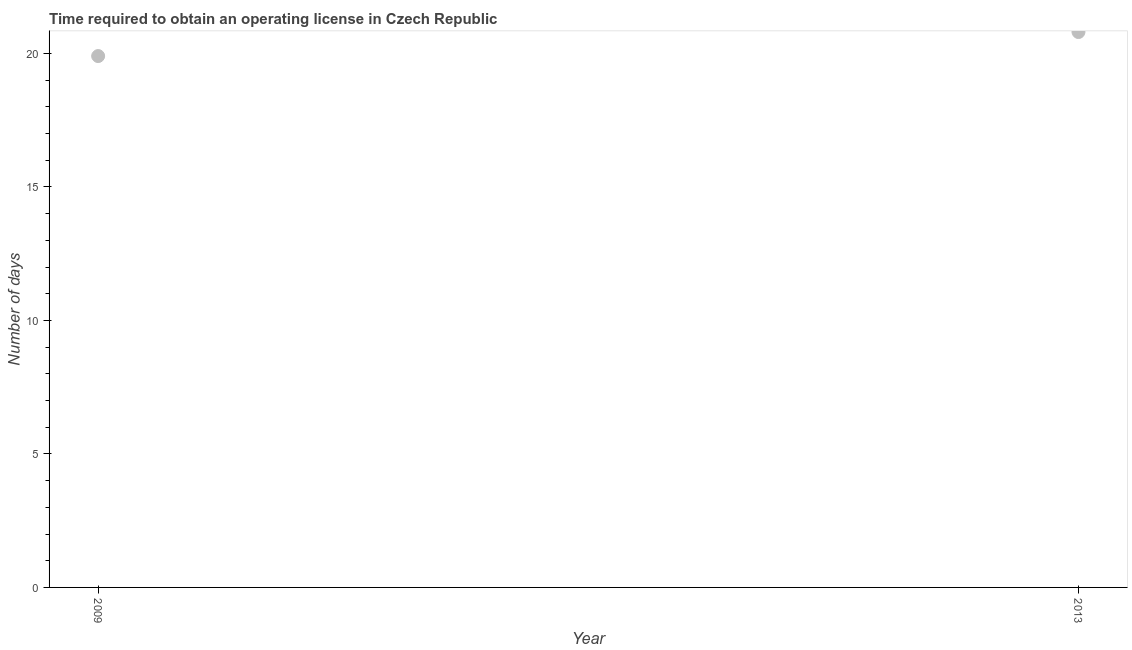What is the number of days to obtain operating license in 2013?
Your answer should be compact. 20.8. Across all years, what is the maximum number of days to obtain operating license?
Your response must be concise. 20.8. In which year was the number of days to obtain operating license maximum?
Keep it short and to the point. 2013. What is the sum of the number of days to obtain operating license?
Ensure brevity in your answer.  40.7. What is the difference between the number of days to obtain operating license in 2009 and 2013?
Provide a short and direct response. -0.9. What is the average number of days to obtain operating license per year?
Your response must be concise. 20.35. What is the median number of days to obtain operating license?
Your answer should be very brief. 20.35. In how many years, is the number of days to obtain operating license greater than 8 days?
Your response must be concise. 2. What is the ratio of the number of days to obtain operating license in 2009 to that in 2013?
Make the answer very short. 0.96. Is the number of days to obtain operating license in 2009 less than that in 2013?
Your answer should be very brief. Yes. In how many years, is the number of days to obtain operating license greater than the average number of days to obtain operating license taken over all years?
Your response must be concise. 1. Does the number of days to obtain operating license monotonically increase over the years?
Offer a very short reply. Yes. How many dotlines are there?
Ensure brevity in your answer.  1. How many years are there in the graph?
Give a very brief answer. 2. What is the difference between two consecutive major ticks on the Y-axis?
Offer a terse response. 5. Are the values on the major ticks of Y-axis written in scientific E-notation?
Give a very brief answer. No. Does the graph contain grids?
Offer a terse response. No. What is the title of the graph?
Your response must be concise. Time required to obtain an operating license in Czech Republic. What is the label or title of the Y-axis?
Your answer should be compact. Number of days. What is the Number of days in 2009?
Offer a terse response. 19.9. What is the Number of days in 2013?
Give a very brief answer. 20.8. 